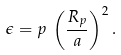<formula> <loc_0><loc_0><loc_500><loc_500>\epsilon = p \, \left ( \frac { R _ { p } } { a } \right ) ^ { 2 } .</formula> 